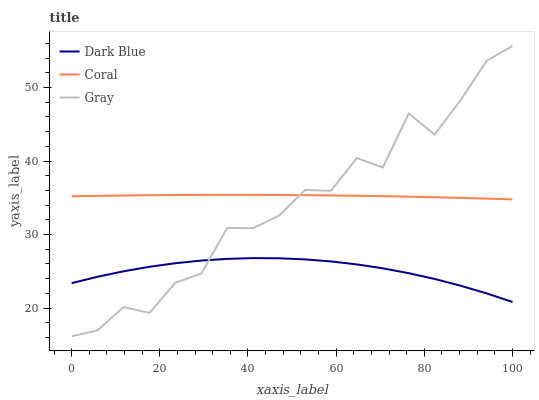Does Dark Blue have the minimum area under the curve?
Answer yes or no. Yes. Does Coral have the maximum area under the curve?
Answer yes or no. Yes. Does Gray have the minimum area under the curve?
Answer yes or no. No. Does Gray have the maximum area under the curve?
Answer yes or no. No. Is Coral the smoothest?
Answer yes or no. Yes. Is Gray the roughest?
Answer yes or no. Yes. Is Gray the smoothest?
Answer yes or no. No. Is Coral the roughest?
Answer yes or no. No. Does Gray have the lowest value?
Answer yes or no. Yes. Does Coral have the lowest value?
Answer yes or no. No. Does Gray have the highest value?
Answer yes or no. Yes. Does Coral have the highest value?
Answer yes or no. No. Is Dark Blue less than Coral?
Answer yes or no. Yes. Is Coral greater than Dark Blue?
Answer yes or no. Yes. Does Dark Blue intersect Gray?
Answer yes or no. Yes. Is Dark Blue less than Gray?
Answer yes or no. No. Is Dark Blue greater than Gray?
Answer yes or no. No. Does Dark Blue intersect Coral?
Answer yes or no. No. 